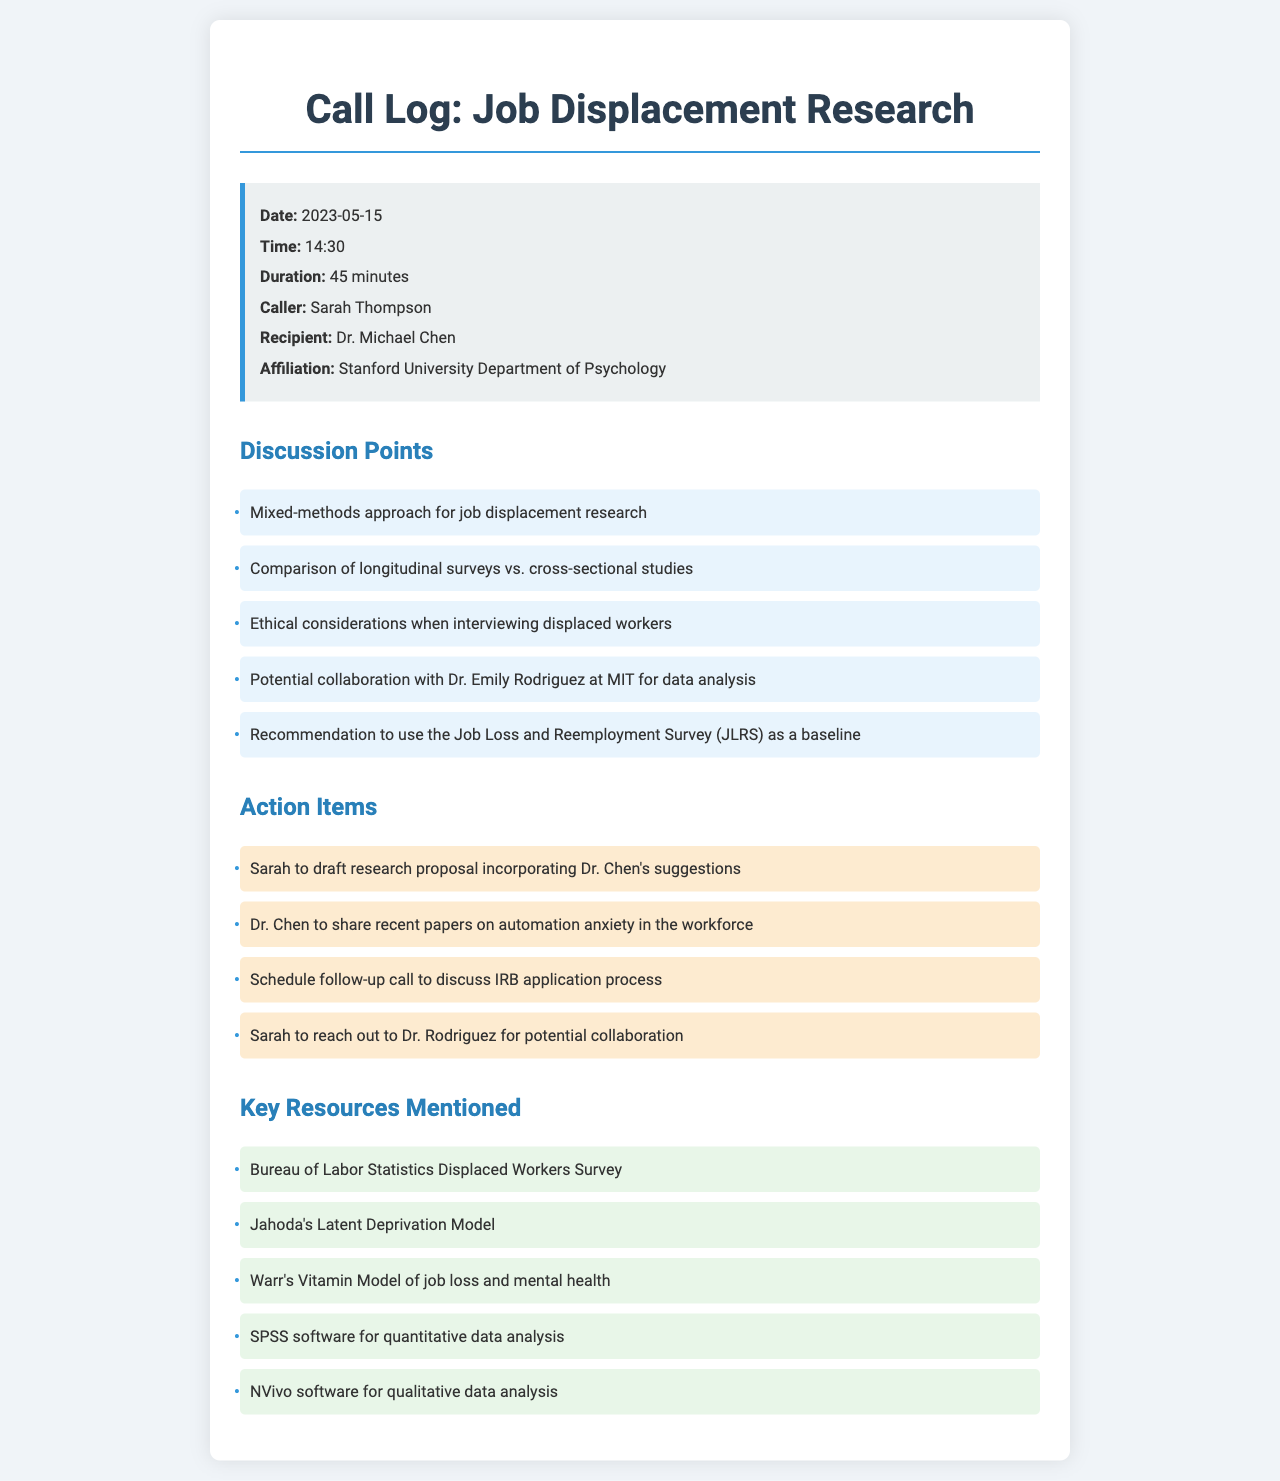What is the date of the call? The date of the call is provided in the call info section of the document.
Answer: 2023-05-15 Who is the caller? The caller's name is listed in the call info section of the document.
Answer: Sarah Thompson What is the duration of the call? The duration of the call is mentioned in the call info section of the document.
Answer: 45 minutes What research methodology was discussed? The methodology discussed is listed under the discussion points in the document.
Answer: Mixed-methods approach What is one of the ethical considerations mentioned? The ethical considerations are part of the discussion points in the document.
Answer: Interviewing displaced workers Who will share recent papers? The individual responsible for sharing recent papers is mentioned in the action items section.
Answer: Dr. Chen What resource is recommended as a baseline for research? The recommended resource is identified in the discussion points of the document.
Answer: Job Loss and Reemployment Survey (JLRS) Which software is suggested for qualitative data analysis? The software suggested is part of the resources listed in the document.
Answer: NVivo software What is the affiliation of Dr. Michael Chen? The affiliation of Dr. Michael Chen is provided in the call info section.
Answer: Stanford University Department of Psychology 